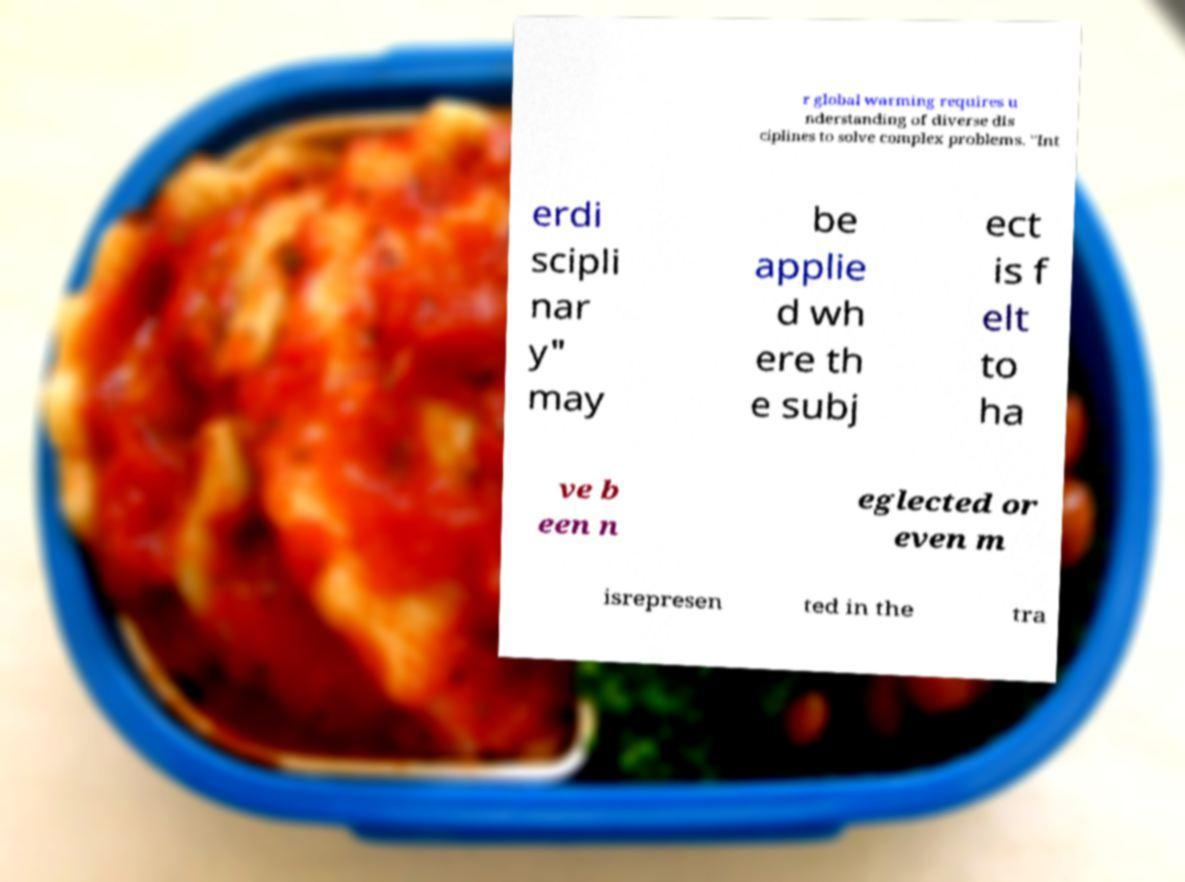Please identify and transcribe the text found in this image. r global warming requires u nderstanding of diverse dis ciplines to solve complex problems. "Int erdi scipli nar y" may be applie d wh ere th e subj ect is f elt to ha ve b een n eglected or even m isrepresen ted in the tra 